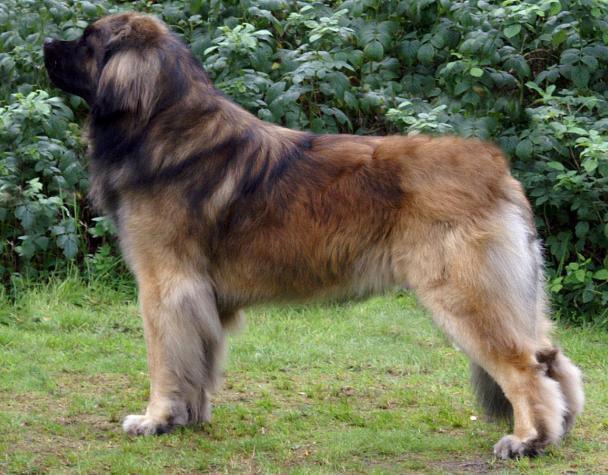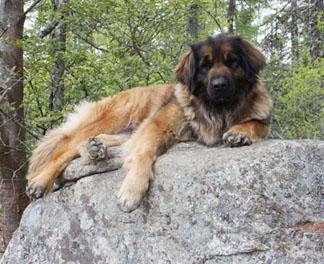The first image is the image on the left, the second image is the image on the right. For the images displayed, is the sentence "The single dog in the left image appears to be lying down." factually correct? Answer yes or no. No. The first image is the image on the left, the second image is the image on the right. For the images shown, is this caption "All of the dogs are outside and some of them are sleeping." true? Answer yes or no. No. 